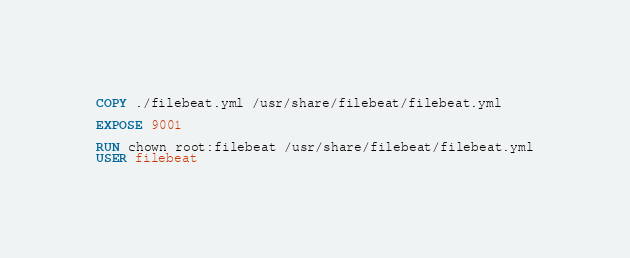Convert code to text. <code><loc_0><loc_0><loc_500><loc_500><_Dockerfile_>COPY ./filebeat.yml /usr/share/filebeat/filebeat.yml

EXPOSE 9001

RUN chown root:filebeat /usr/share/filebeat/filebeat.yml
USER filebeat
</code> 